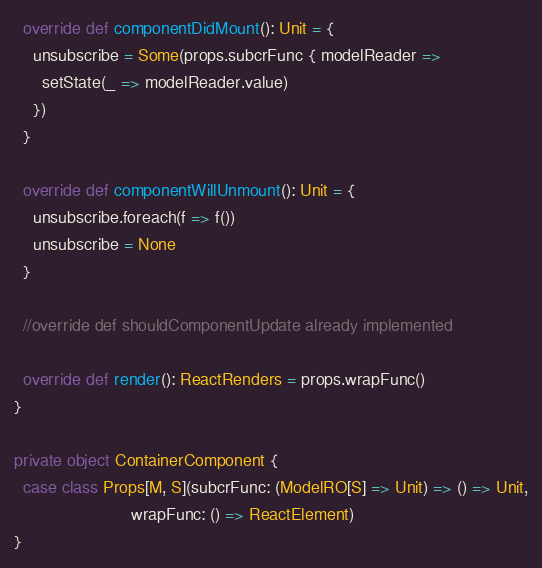<code> <loc_0><loc_0><loc_500><loc_500><_Scala_>  override def componentDidMount(): Unit = {
    unsubscribe = Some(props.subcrFunc { modelReader =>
      setState(_ => modelReader.value)
    })
  }

  override def componentWillUnmount(): Unit = {
    unsubscribe.foreach(f => f())
    unsubscribe = None
  }

  //override def shouldComponentUpdate already implemented

  override def render(): ReactRenders = props.wrapFunc()
}

private object ContainerComponent {
  case class Props[M, S](subcrFunc: (ModelRO[S] => Unit) => () => Unit,
                         wrapFunc: () => ReactElement)
}
</code> 